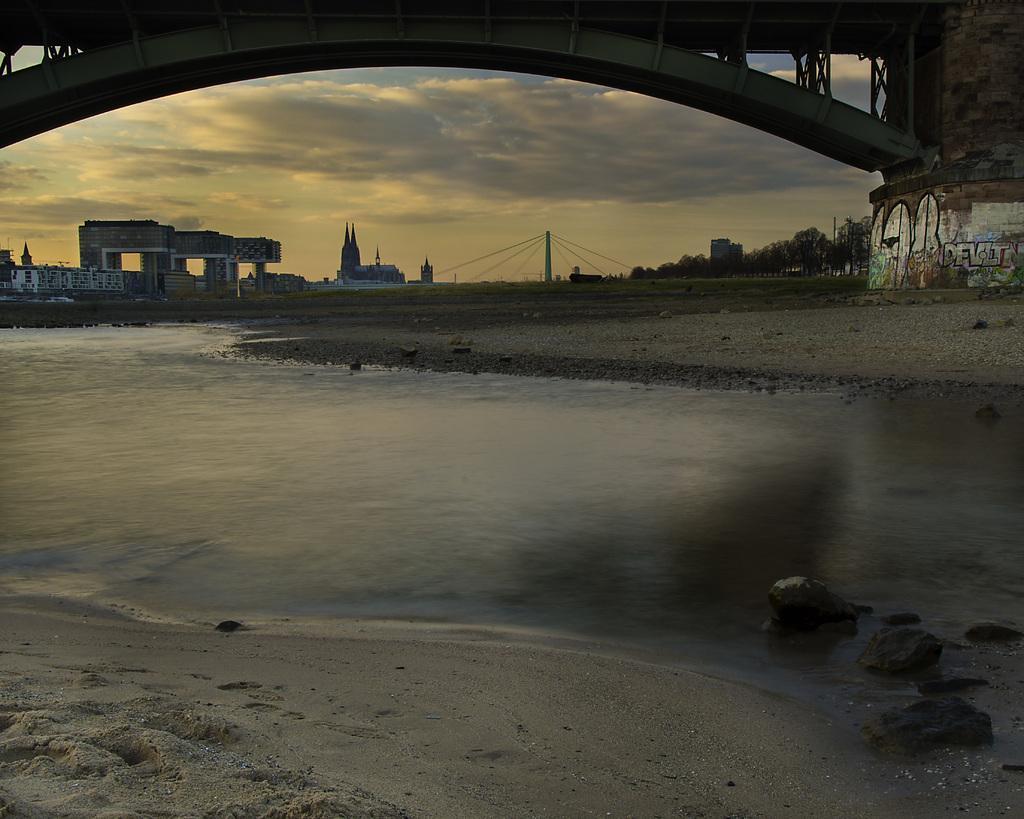In one or two sentences, can you explain what this image depicts? In this image I can see the water, the ground and a bridge. In the background I can see few buildings, few trees and the sky. 